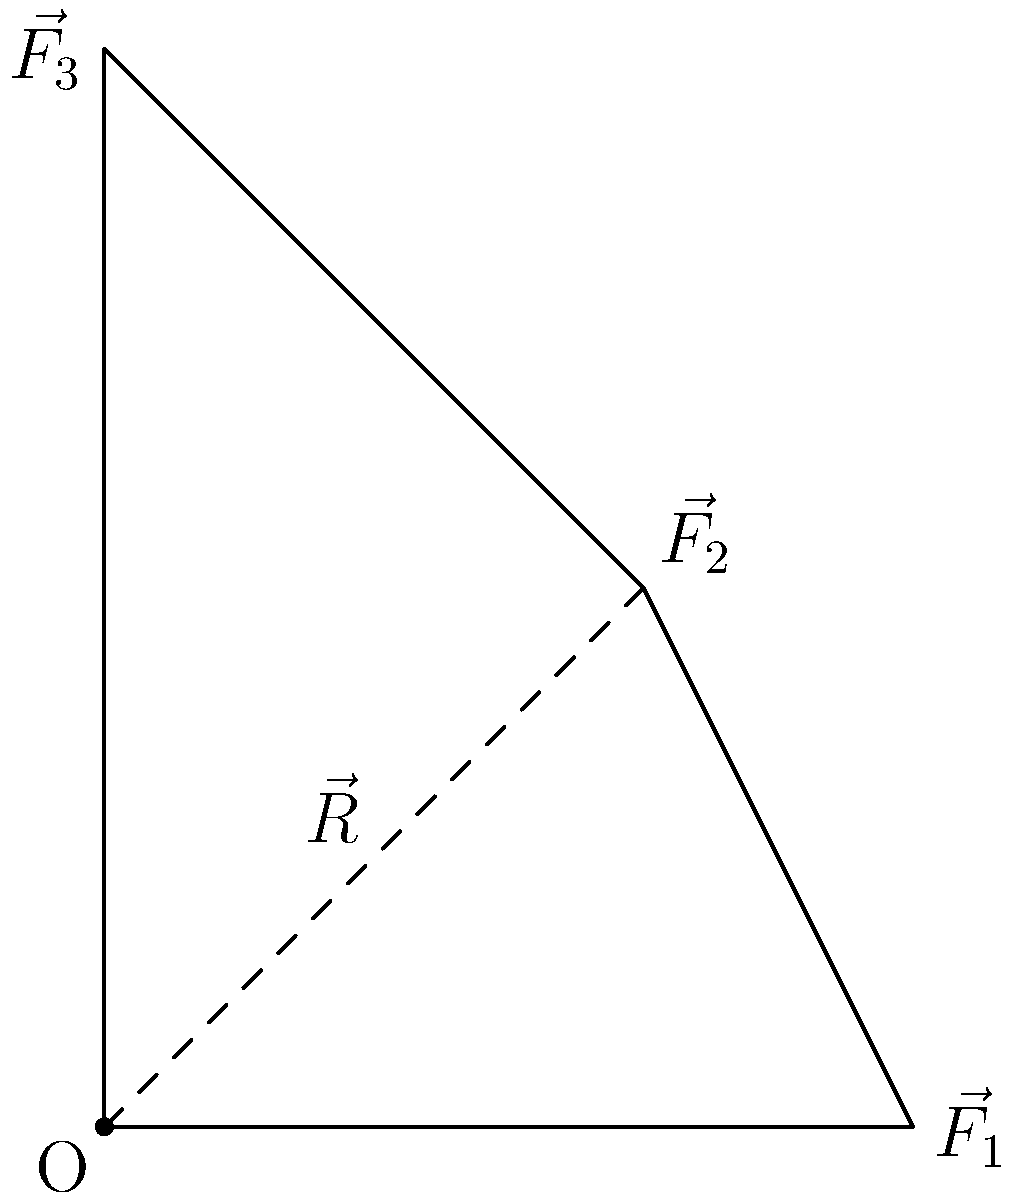During a fishing tournament, you notice that your fishing line is affected by multiple forces: a 3N force from the current ($\vec{F_1}$), a 2.8N force from the wind ($\vec{F_2}$), and a 4N force from a biting fish ($\vec{F_3}$). Given the vector diagram, calculate the magnitude of the resultant force $\vec{R}$ on your fishing line. To find the magnitude of the resultant force, we'll follow these steps:

1) First, we need to find the components of $\vec{R}$. From the diagram, we can see that:
   $R_x = F_1 - F_2\cos45°$
   $R_y = F_2\sin45° + F_3$

2) Calculate $R_x$:
   $R_x = 3 - 2.8\cos45° = 3 - 2.8 \cdot \frac{\sqrt{2}}{2} = 3 - 1.98 = 1.02$ N

3) Calculate $R_y$:
   $R_y = 2.8\sin45° + 4 = 2.8 \cdot \frac{\sqrt{2}}{2} + 4 = 1.98 + 4 = 5.98$ N

4) Use the Pythagorean theorem to find the magnitude of $\vec{R}$:
   $|\vec{R}| = \sqrt{R_x^2 + R_y^2} = \sqrt{1.02^2 + 5.98^2} = \sqrt{1.0404 + 35.7604} = \sqrt{36.8008} = 6.07$ N

Therefore, the magnitude of the resultant force on your fishing line is approximately 6.07 N.
Answer: 6.07 N 